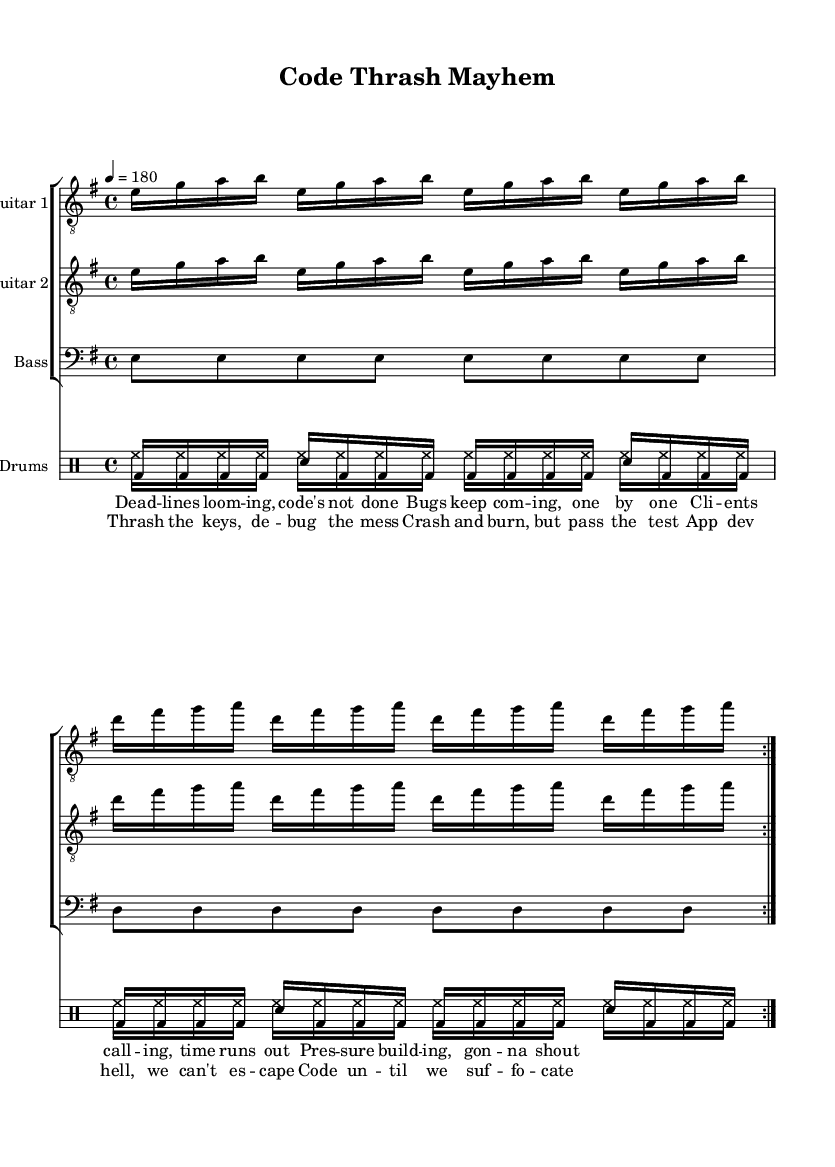What is the key signature of this music? The key signature appears as two sharps which indicates that the piece is in E minor. This can be observed near the beginning of the sheet music, where the key signature is stated.
Answer: E minor What is the time signature of this music? The time signature is noted as 4/4, shown at the start of the score. This means there are four beats in each measure and the quarter note gets one beat.
Answer: 4/4 What is the tempo marking for this piece? The tempo marking is provided as "4 = 180," indicating that the quarter note is to be played at 180 beats per minute. This is typically found at the beginning of the score as well.
Answer: 180 How many times do the verses repeat? The verses are indicated to repeat by the "volta" marking, which shows that the section is repeated two times. This can be seen through the repeat signs in the "verse" section of the score.
Answer: 2 What rhythmic motif is used in the bass part? The bass part contains a constant eighth-note motif alternating between E and D notes. This can be determined by analyzing the rhythmic values and the note structure in the bass line.
Answer: E and D What is the primary theme expressed in the lyrics? The lyrics convey a strong sense of pressure and urgency related to app development deadlines. This can be inferred by the phrases "time runs out" and "thrash the keys," highlighting the frantic pace of coding under stress.
Answer: Pressure and urgency How does the drumming pattern contribute to the thrash metal feel? The drumming pattern incorporates fast-paced bass drums and snare hits with consistent hi-hat plays, typical of thrash metal to create driving energy. This can be assessed by looking at the drum notation in the score, which exhibits rapid rhythmic sequences.
Answer: Fast-paced and energetic 